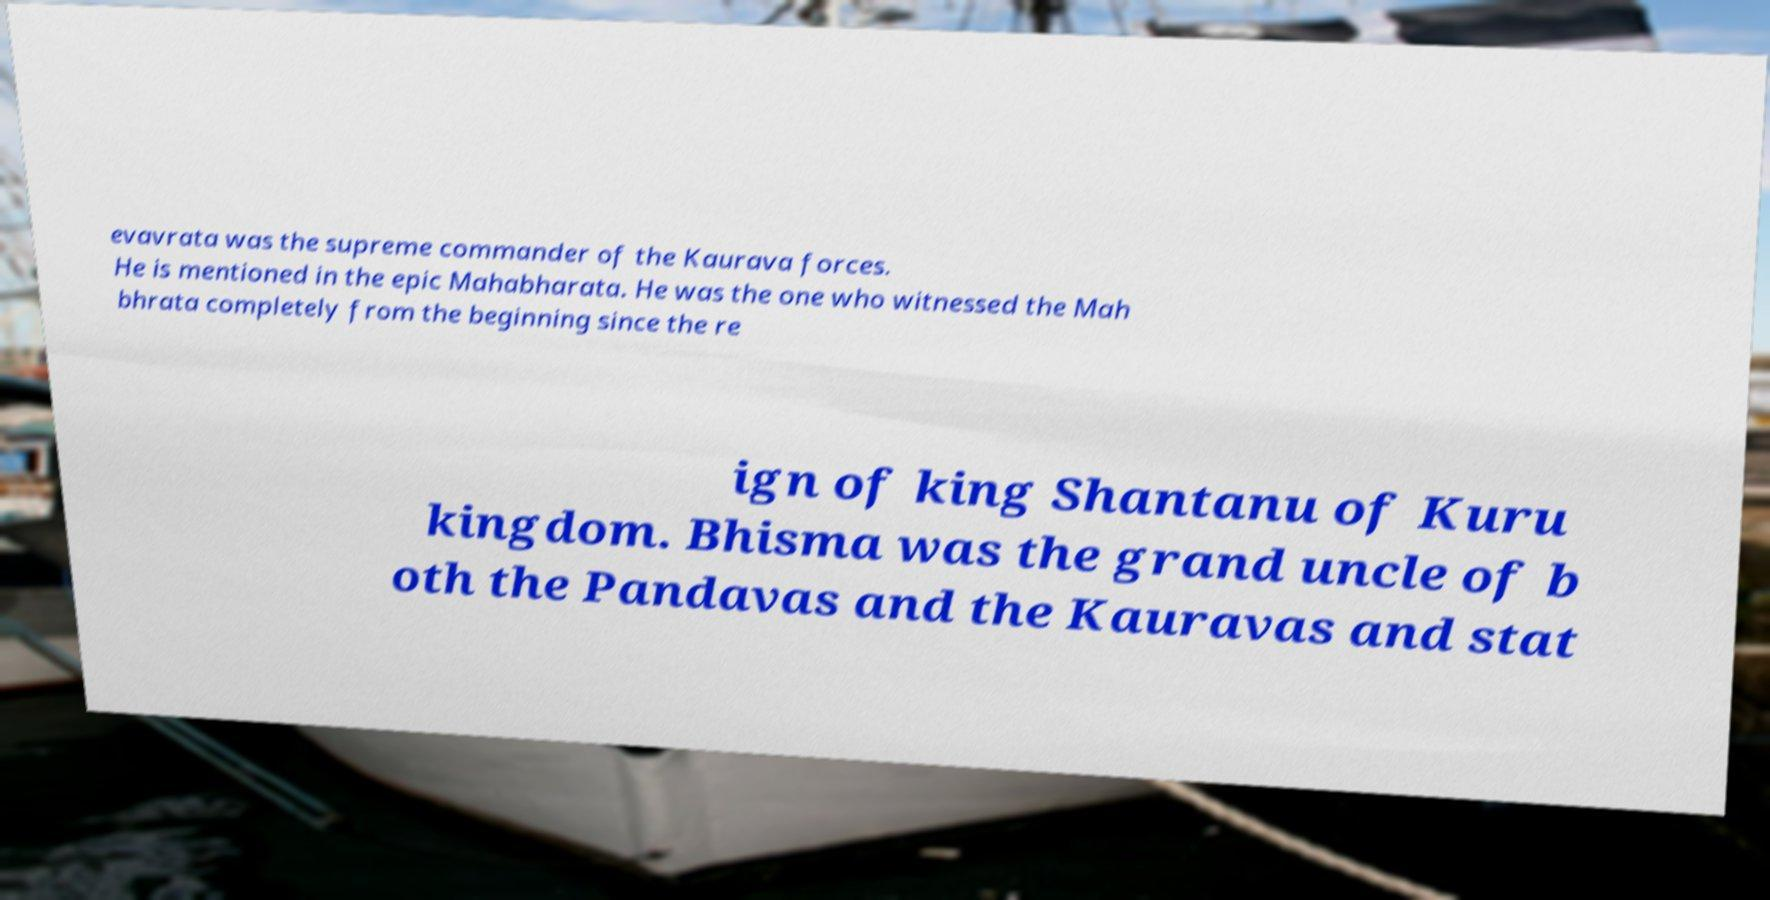Can you read and provide the text displayed in the image?This photo seems to have some interesting text. Can you extract and type it out for me? evavrata was the supreme commander of the Kaurava forces. He is mentioned in the epic Mahabharata. He was the one who witnessed the Mah bhrata completely from the beginning since the re ign of king Shantanu of Kuru kingdom. Bhisma was the grand uncle of b oth the Pandavas and the Kauravas and stat 